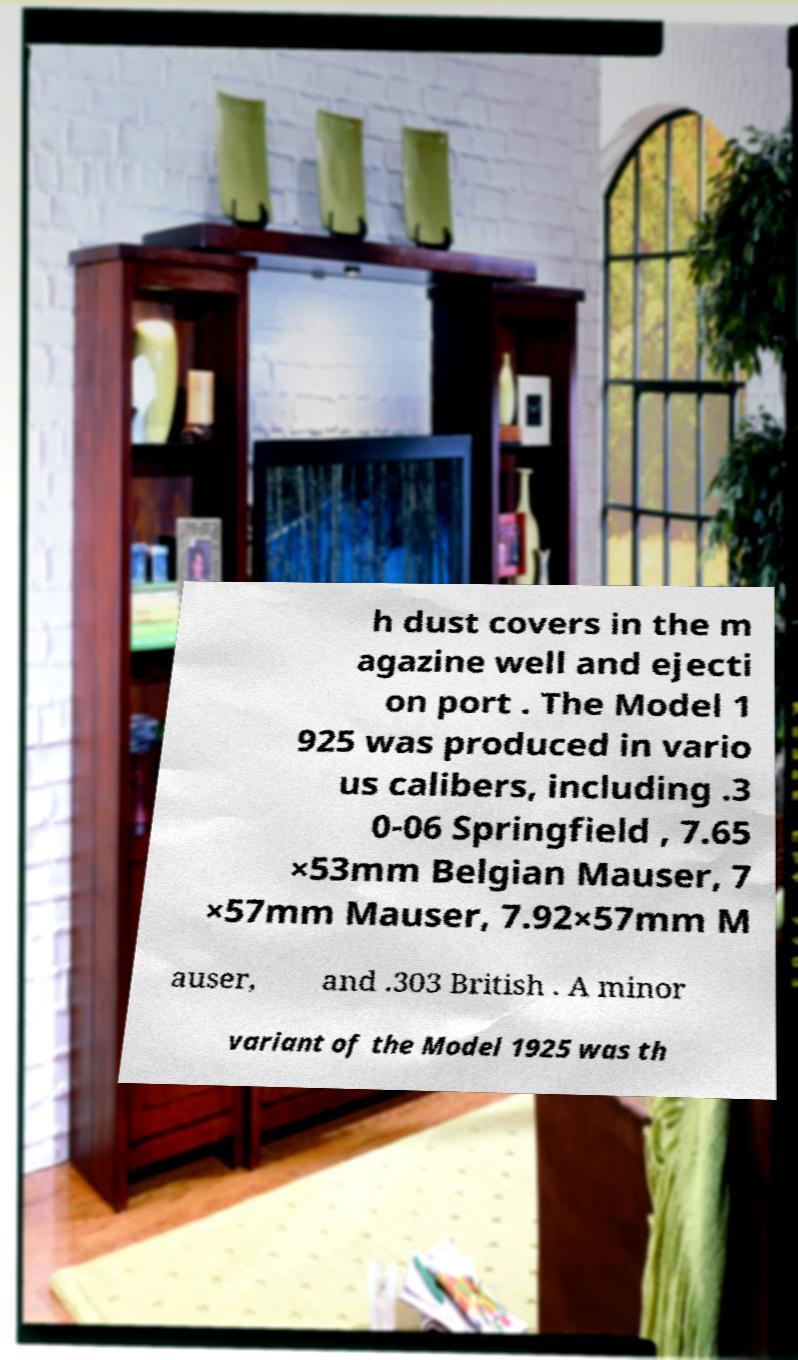Can you accurately transcribe the text from the provided image for me? h dust covers in the m agazine well and ejecti on port . The Model 1 925 was produced in vario us calibers, including .3 0-06 Springfield , 7.65 ×53mm Belgian Mauser, 7 ×57mm Mauser, 7.92×57mm M auser, and .303 British . A minor variant of the Model 1925 was th 